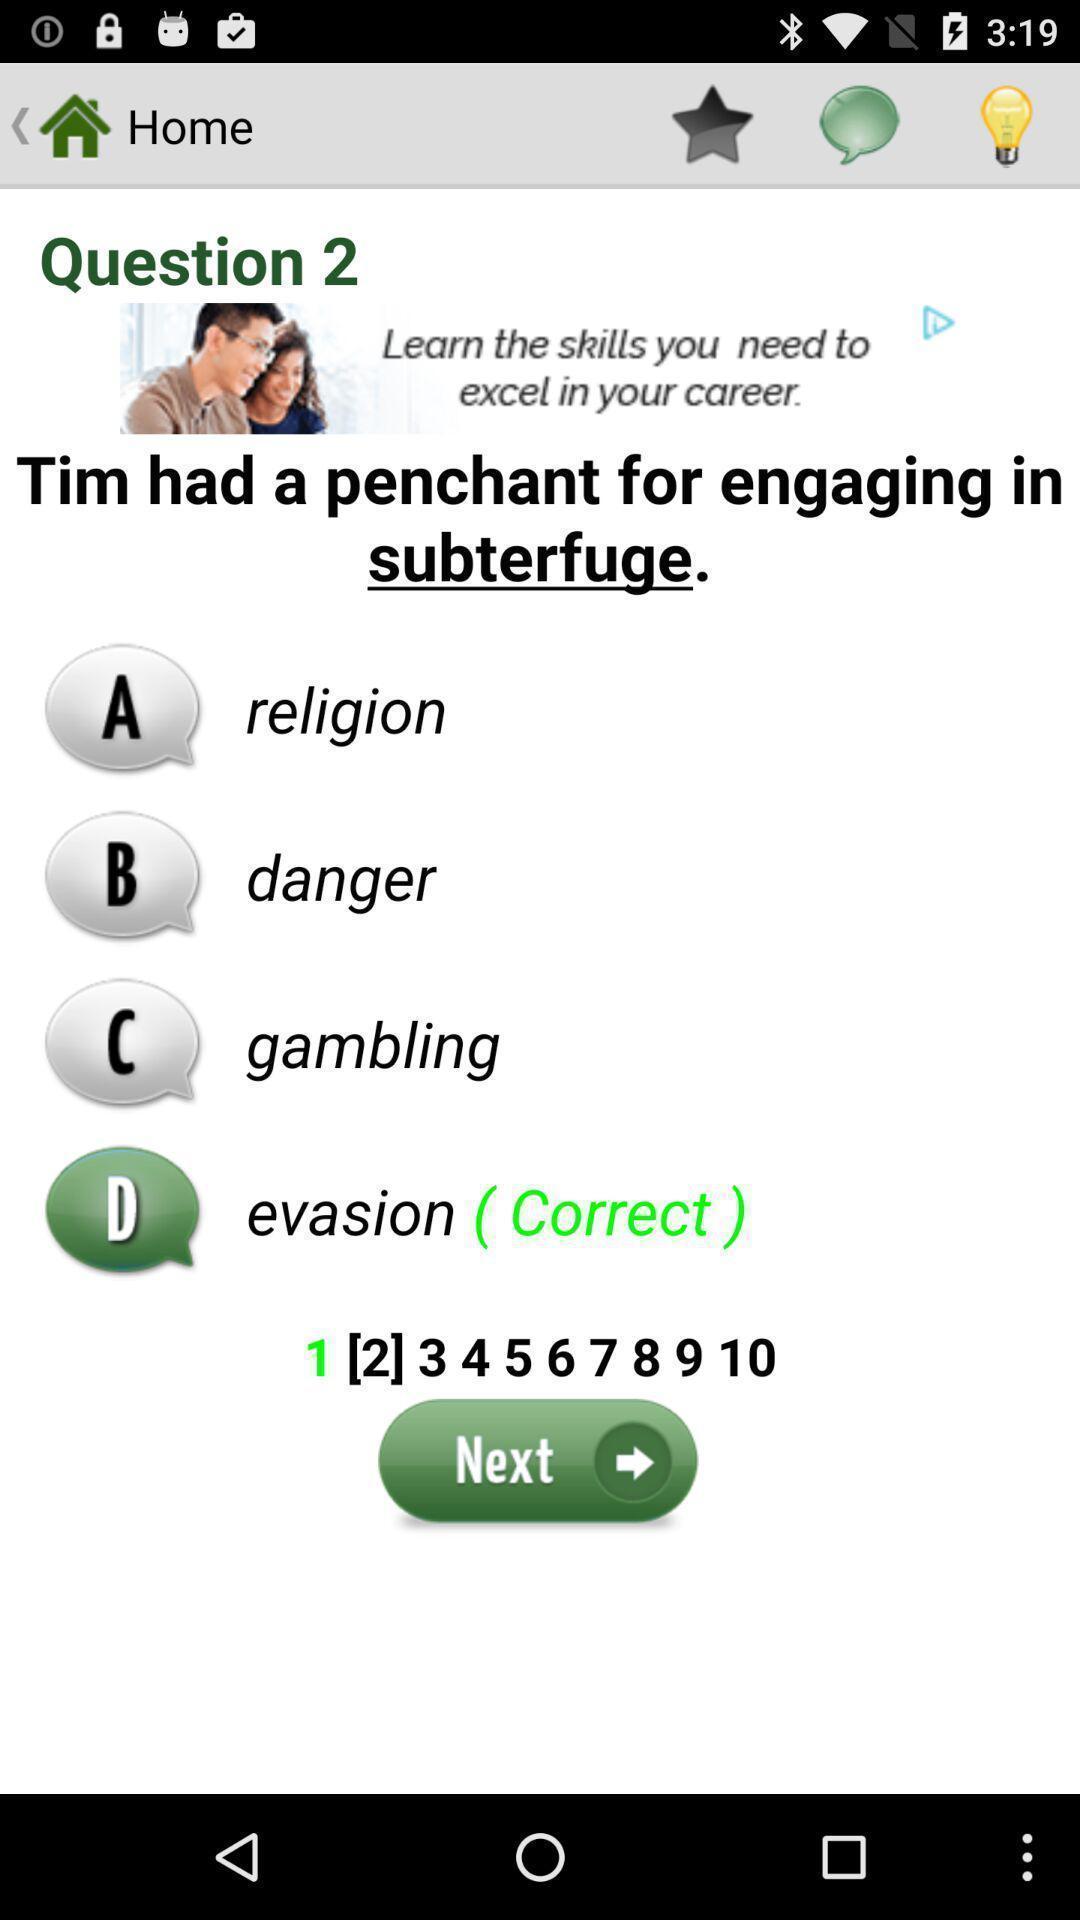What is the overall content of this screenshot? Screen showing home page. 